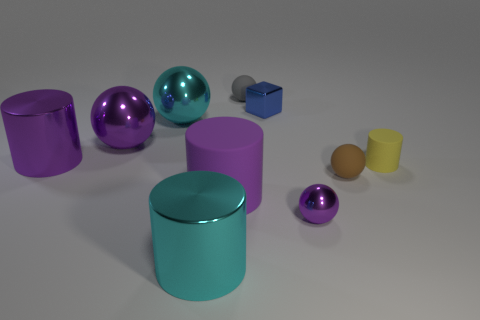What material is the cyan thing that is the same shape as the gray matte thing?
Ensure brevity in your answer.  Metal. Do the small gray matte thing and the brown rubber thing have the same shape?
Provide a short and direct response. Yes. There is a large purple matte thing; what number of metallic blocks are behind it?
Ensure brevity in your answer.  1. There is a large cyan object that is in front of the shiny cylinder to the left of the cyan metal ball; what is its shape?
Ensure brevity in your answer.  Cylinder. There is a small purple object that is made of the same material as the big purple sphere; what is its shape?
Your answer should be very brief. Sphere. There is a cylinder on the right side of the gray matte sphere; is it the same size as the purple metallic ball on the right side of the cube?
Provide a short and direct response. Yes. What is the shape of the big cyan metal thing in front of the small purple sphere?
Offer a terse response. Cylinder. The small cylinder is what color?
Your response must be concise. Yellow. There is a gray ball; is it the same size as the cylinder behind the yellow thing?
Your answer should be compact. No. What number of metallic objects are either large green balls or big purple objects?
Ensure brevity in your answer.  2. 